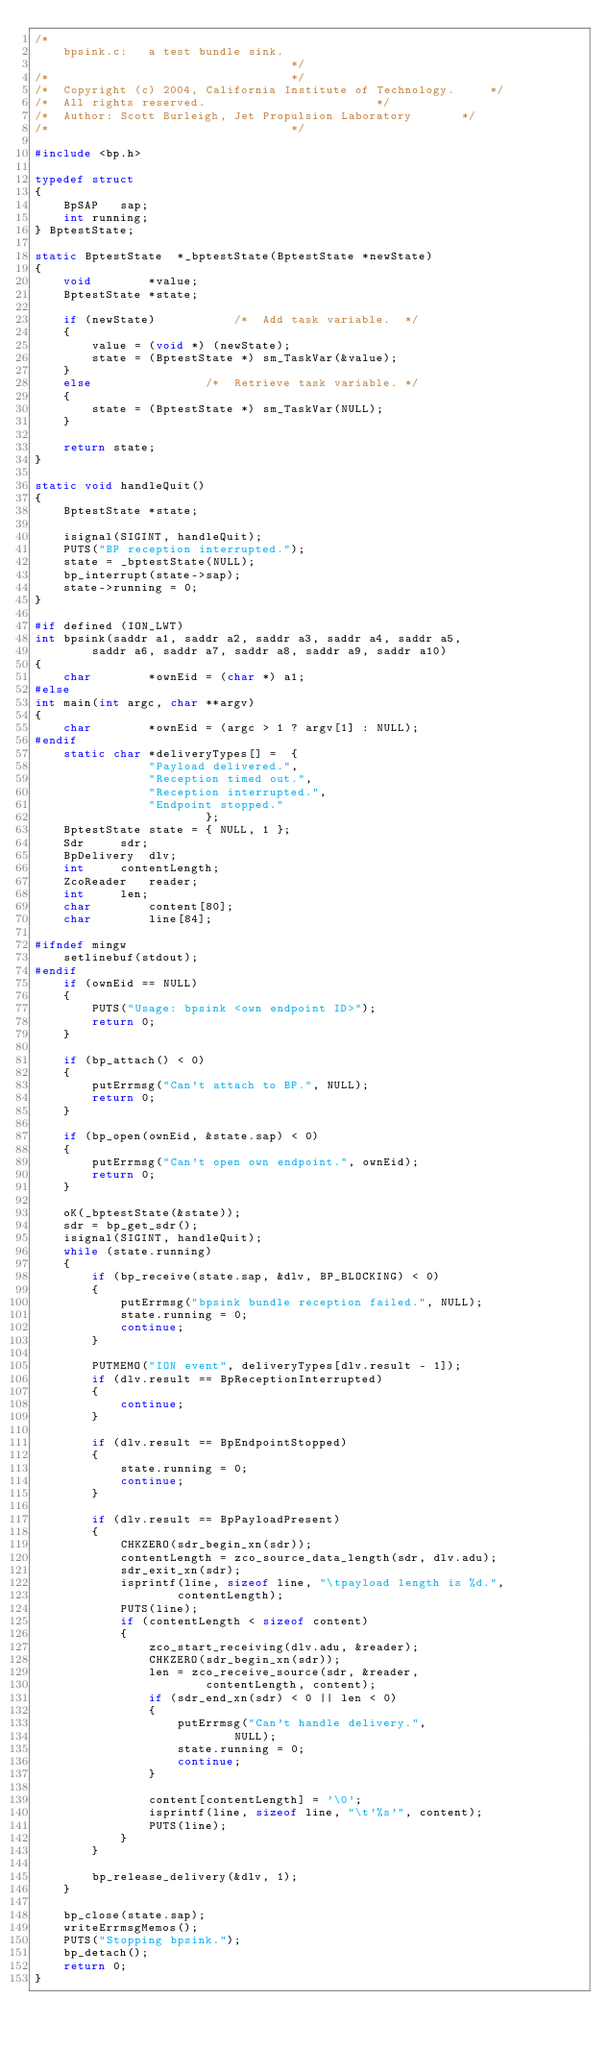<code> <loc_0><loc_0><loc_500><loc_500><_C_>/*
	bpsink.c:	a test bundle sink.
									*/
/*									*/
/*	Copyright (c) 2004, California Institute of Technology.		*/
/*	All rights reserved.						*/
/*	Author: Scott Burleigh, Jet Propulsion Laboratory		*/
/*									*/

#include <bp.h>

typedef struct
{
	BpSAP	sap;
	int	running;
} BptestState;

static BptestState	*_bptestState(BptestState *newState)
{
	void		*value;
	BptestState	*state;

	if (newState)			/*	Add task variable.	*/
	{
		value = (void *) (newState);
		state = (BptestState *) sm_TaskVar(&value);
	}
	else				/*	Retrieve task variable.	*/
	{
		state = (BptestState *) sm_TaskVar(NULL);
	}

	return state;
}

static void	handleQuit()
{
	BptestState	*state;

	isignal(SIGINT, handleQuit);
	PUTS("BP reception interrupted.");
	state = _bptestState(NULL);
	bp_interrupt(state->sap);
	state->running = 0;
}

#if defined (ION_LWT)
int	bpsink(saddr a1, saddr a2, saddr a3, saddr a4, saddr a5,
		saddr a6, saddr a7, saddr a8, saddr a9, saddr a10)
{
	char		*ownEid = (char *) a1;
#else
int	main(int argc, char **argv)
{
	char		*ownEid = (argc > 1 ? argv[1] : NULL);
#endif
	static char	*deliveryTypes[] =	{
				"Payload delivered.",
				"Reception timed out.",
				"Reception interrupted.",
				"Endpoint stopped."
						};
	BptestState	state = { NULL, 1 };
	Sdr		sdr;
	BpDelivery	dlv;
	int		contentLength;
	ZcoReader	reader;
	int		len;
	char		content[80];
	char		line[84];

#ifndef mingw
	setlinebuf(stdout);
#endif
	if (ownEid == NULL)
	{
		PUTS("Usage: bpsink <own endpoint ID>");
		return 0;
	}

	if (bp_attach() < 0)
	{
		putErrmsg("Can't attach to BP.", NULL);
		return 0;
	}

	if (bp_open(ownEid, &state.sap) < 0)
	{
		putErrmsg("Can't open own endpoint.", ownEid);
		return 0;
	}

	oK(_bptestState(&state));
	sdr = bp_get_sdr();
	isignal(SIGINT, handleQuit);
	while (state.running)
	{
		if (bp_receive(state.sap, &dlv, BP_BLOCKING) < 0)
		{
			putErrmsg("bpsink bundle reception failed.", NULL);
			state.running = 0;
			continue;
		}

		PUTMEMO("ION event", deliveryTypes[dlv.result - 1]);
		if (dlv.result == BpReceptionInterrupted)
		{
			continue;
		}

		if (dlv.result == BpEndpointStopped)
		{
			state.running = 0;
			continue;
		}

		if (dlv.result == BpPayloadPresent)
		{
			CHKZERO(sdr_begin_xn(sdr));
			contentLength = zco_source_data_length(sdr, dlv.adu);
			sdr_exit_xn(sdr);
			isprintf(line, sizeof line, "\tpayload length is %d.",
					contentLength);
			PUTS(line);
			if (contentLength < sizeof content)
			{
				zco_start_receiving(dlv.adu, &reader);
				CHKZERO(sdr_begin_xn(sdr));
				len = zco_receive_source(sdr, &reader,
						contentLength, content);
				if (sdr_end_xn(sdr) < 0 || len < 0)
				{
					putErrmsg("Can't handle delivery.",
							NULL);
					state.running = 0;
					continue;
				}

				content[contentLength] = '\0';
				isprintf(line, sizeof line, "\t'%s'", content);
				PUTS(line);
			}
		}

		bp_release_delivery(&dlv, 1);
	}

	bp_close(state.sap);
	writeErrmsgMemos();
	PUTS("Stopping bpsink.");
	bp_detach();
	return 0;
}
</code> 